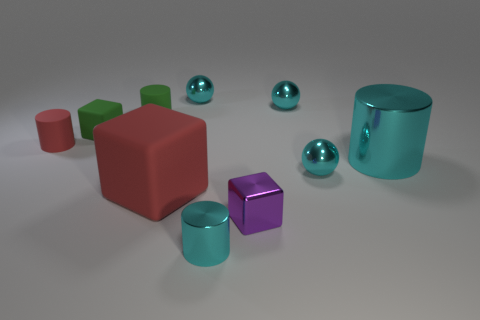Subtract all cyan balls. How many were subtracted if there are2cyan balls left? 1 Subtract 0 red spheres. How many objects are left? 10 Subtract all cubes. How many objects are left? 7 Subtract all big green balls. Subtract all red cubes. How many objects are left? 9 Add 9 big cylinders. How many big cylinders are left? 10 Add 2 small matte cylinders. How many small matte cylinders exist? 4 